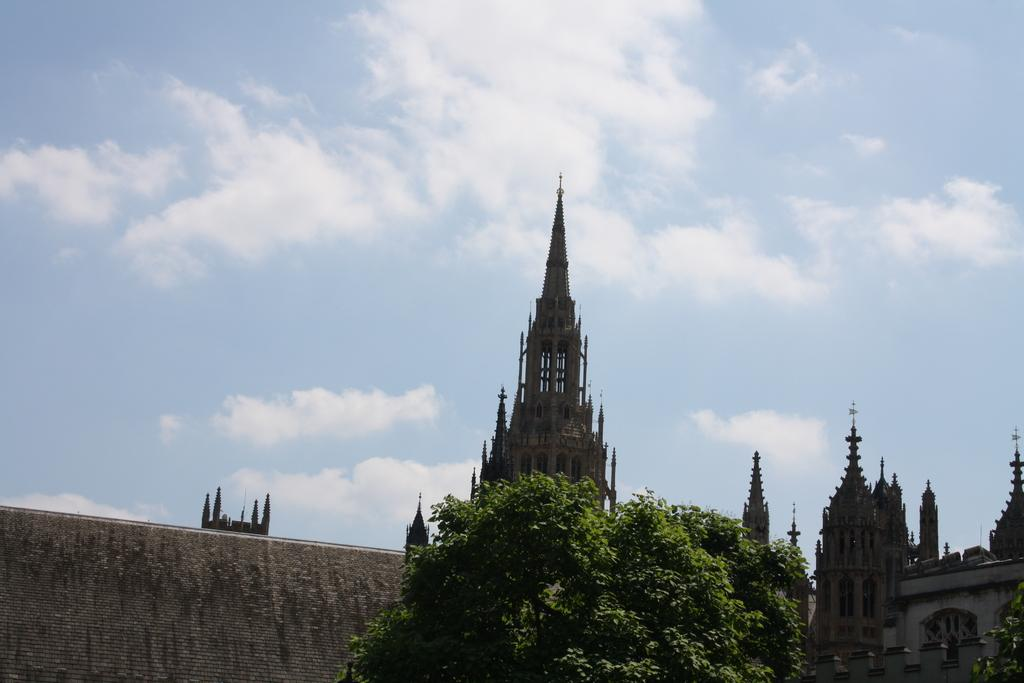What can be seen in the sky in the image? The sky is visible in the image, and clouds are present. What type of structures can be seen in the image? There are buildings in the image. What type of vegetation is present in the image? Trees are present in the image. Can you see a nest in the trees in the image? There is no nest visible in the trees in the image. What type of tail is attached to the clouds in the image? Clouds do not have tails, and there is no such object present in the image. 